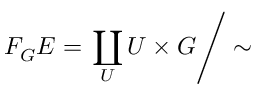Convert formula to latex. <formula><loc_0><loc_0><loc_500><loc_500>F _ { G } E = \coprod _ { U } U \times G \right / \sim</formula> 